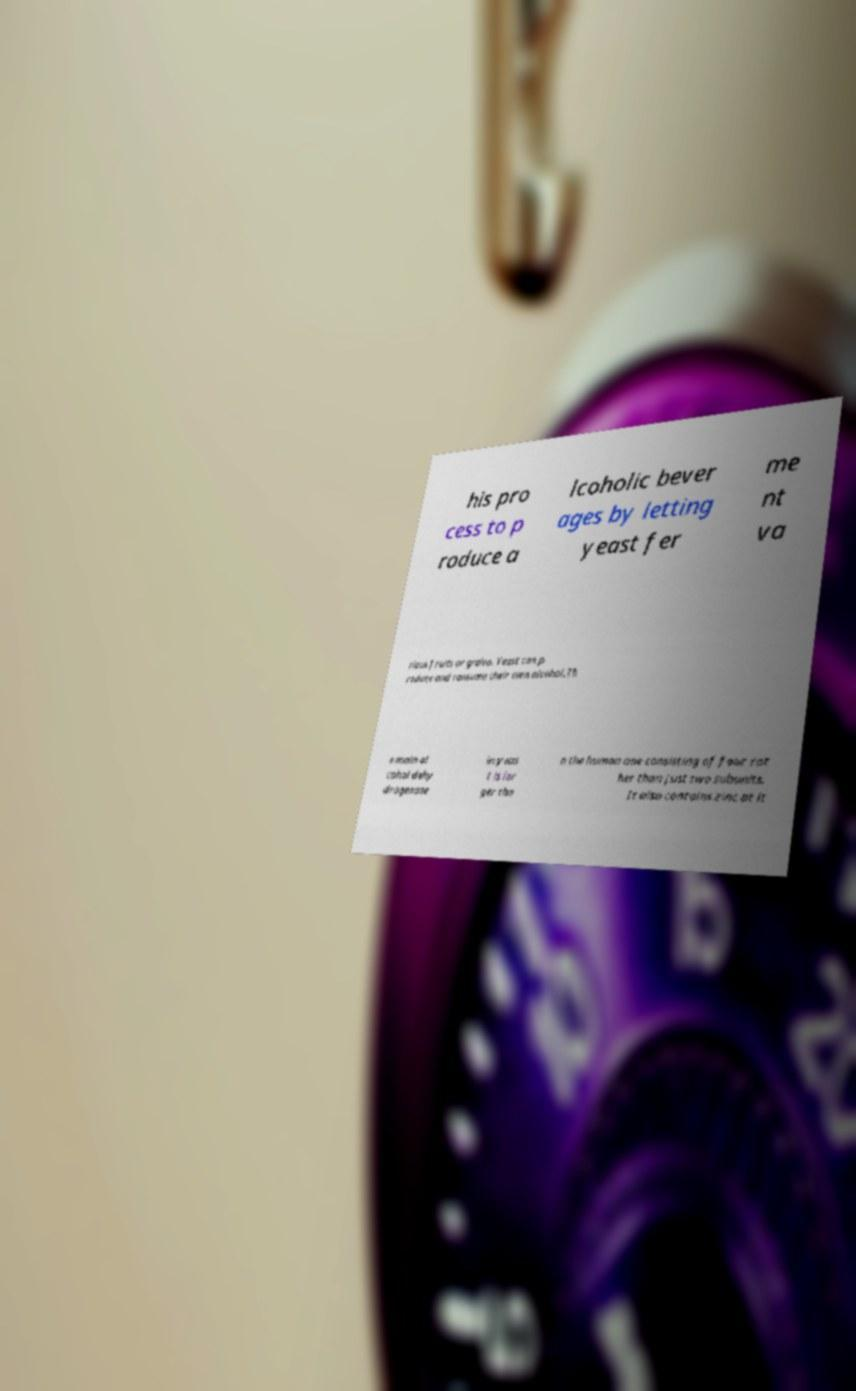Please read and relay the text visible in this image. What does it say? his pro cess to p roduce a lcoholic bever ages by letting yeast fer me nt va rious fruits or grains. Yeast can p roduce and consume their own alcohol.Th e main al cohol dehy drogenase in yeas t is lar ger tha n the human one consisting of four rat her than just two subunits. It also contains zinc at it 